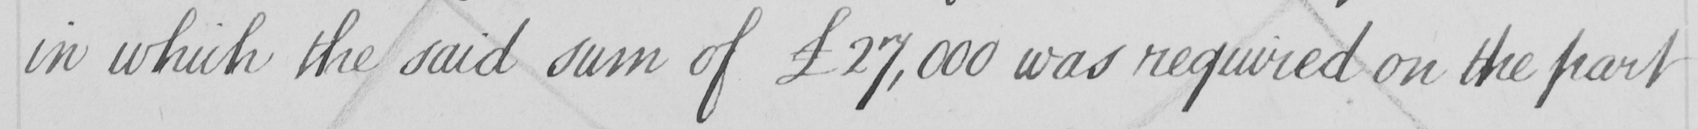What does this handwritten line say? in which the said sum of £27,000 was required on the part 